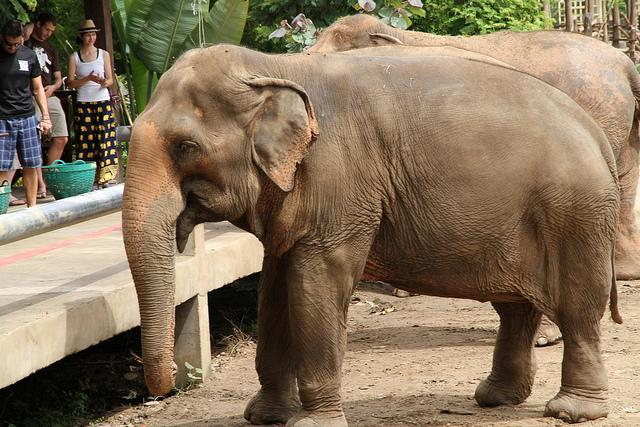What is this place?

Choices:
A) resort
B) circus
C) school
D) zoo zoo 